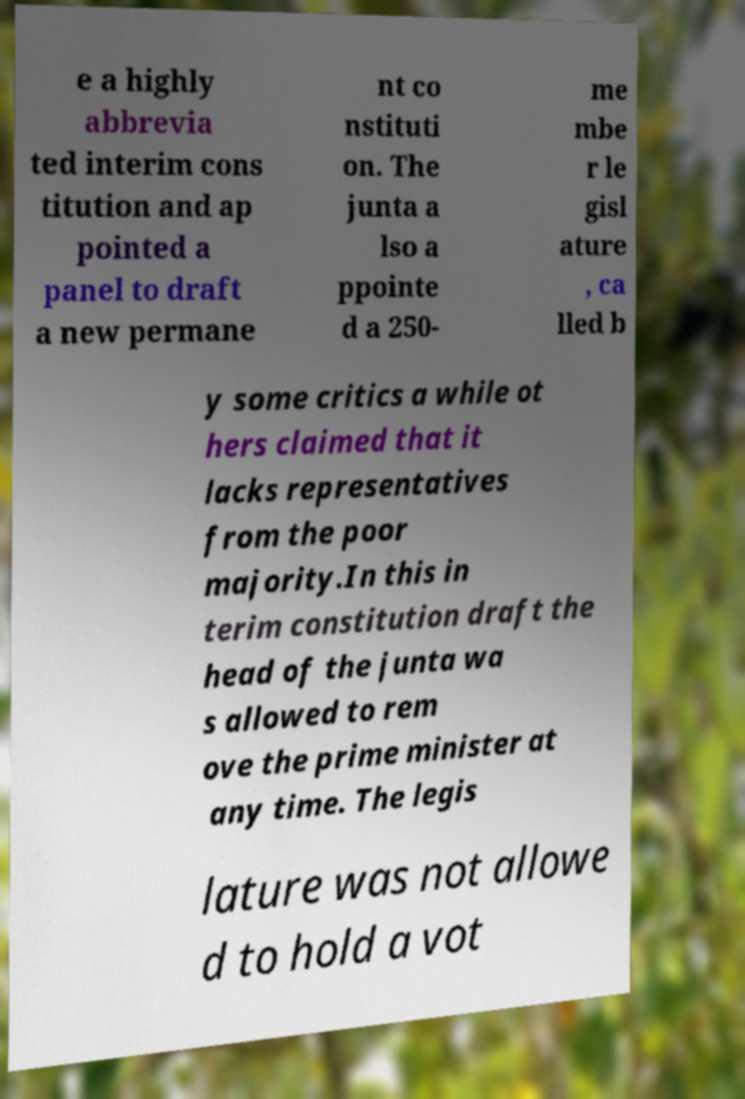For documentation purposes, I need the text within this image transcribed. Could you provide that? e a highly abbrevia ted interim cons titution and ap pointed a panel to draft a new permane nt co nstituti on. The junta a lso a ppointe d a 250- me mbe r le gisl ature , ca lled b y some critics a while ot hers claimed that it lacks representatives from the poor majority.In this in terim constitution draft the head of the junta wa s allowed to rem ove the prime minister at any time. The legis lature was not allowe d to hold a vot 